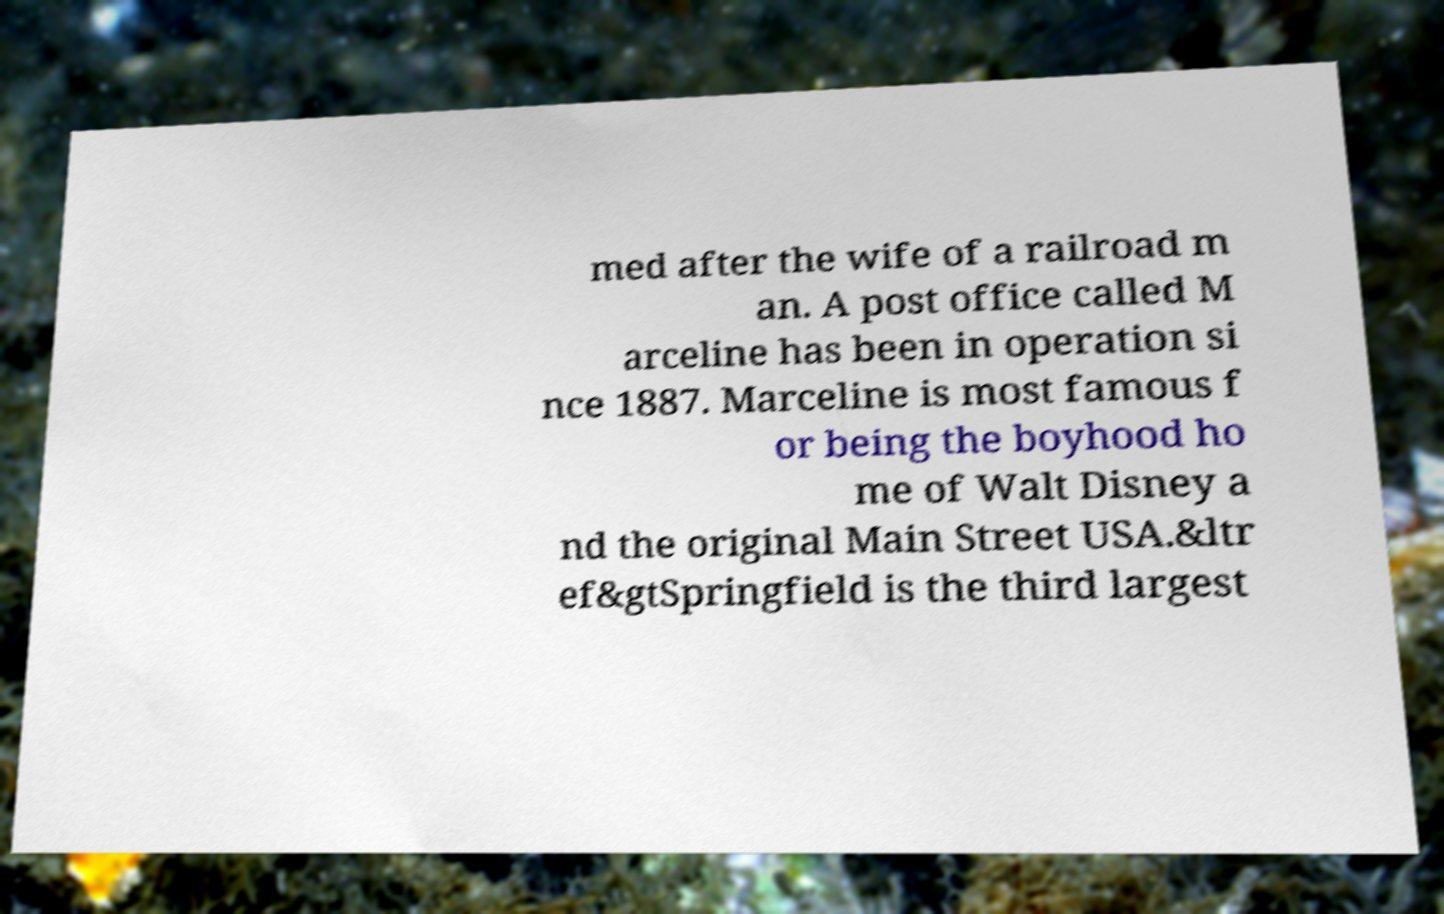There's text embedded in this image that I need extracted. Can you transcribe it verbatim? med after the wife of a railroad m an. A post office called M arceline has been in operation si nce 1887. Marceline is most famous f or being the boyhood ho me of Walt Disney a nd the original Main Street USA.&ltr ef&gtSpringfield is the third largest 